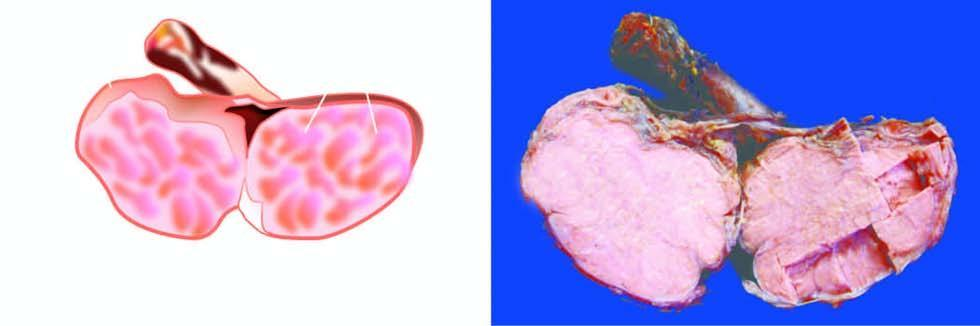what is enlarged but without distorting its contour?
Answer the question using a single word or phrase. Testis 